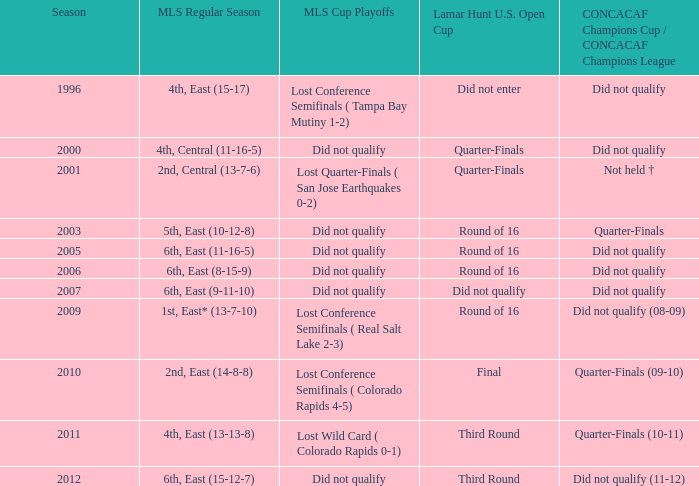In which season was the 6th place team in the eastern conference of mls regular season with a 9-11-10 performance? 2007.0. 